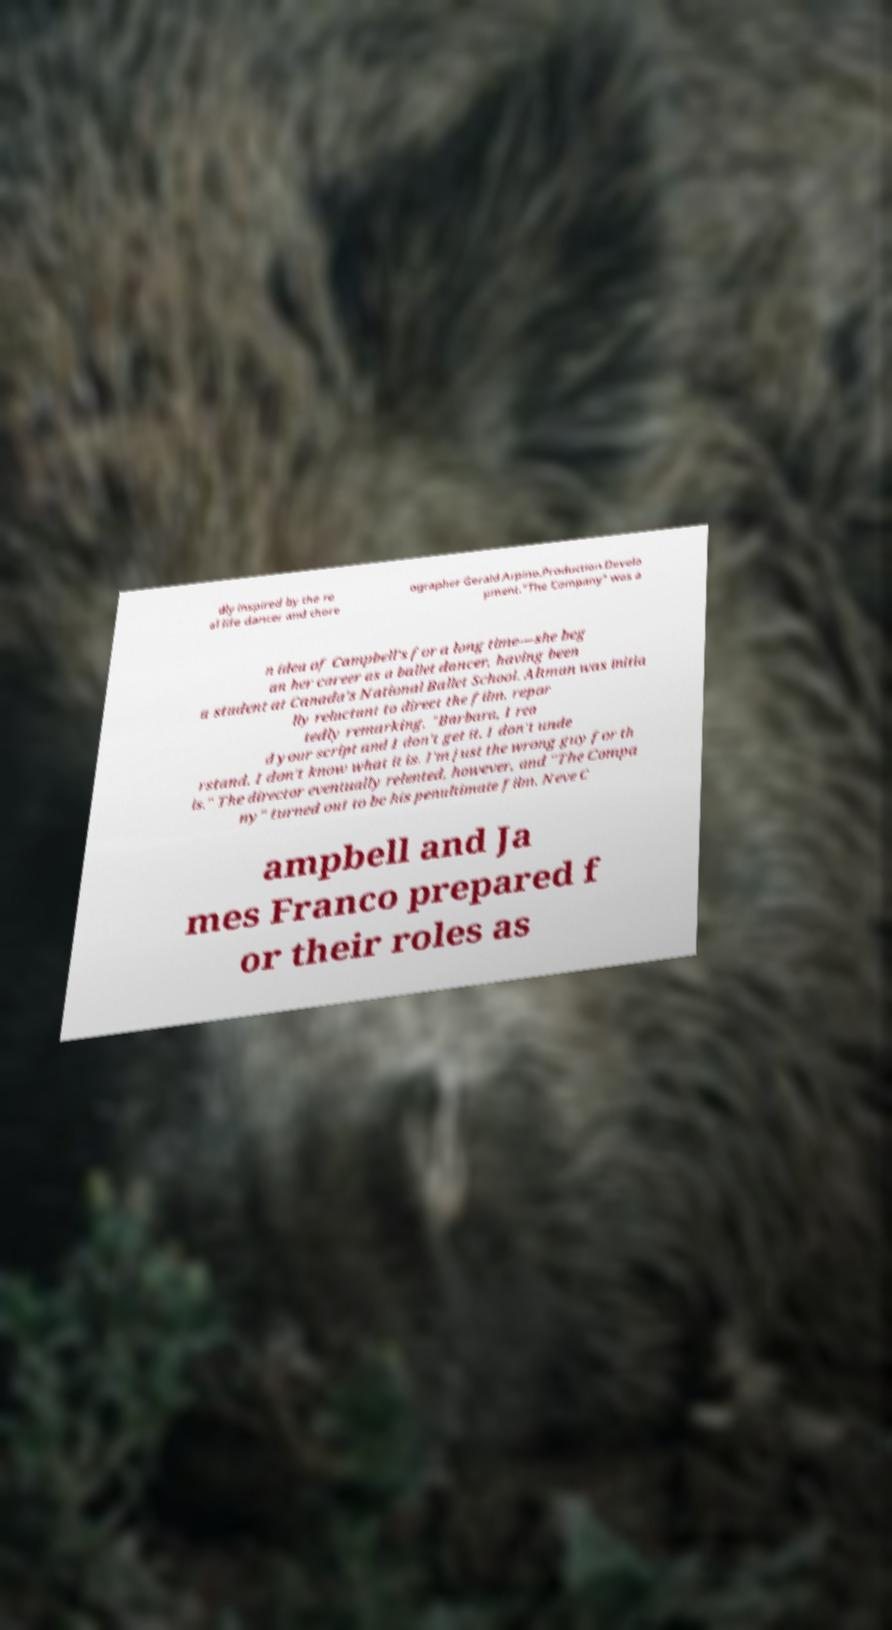Can you read and provide the text displayed in the image?This photo seems to have some interesting text. Can you extract and type it out for me? dly inspired by the re al life dancer and chore ographer Gerald Arpino.Production.Develo pment."The Company" was a n idea of Campbell's for a long time—she beg an her career as a ballet dancer, having been a student at Canada's National Ballet School. Altman was initia lly reluctant to direct the film, repor tedly remarking, "Barbara, I rea d your script and I don't get it. I don't unde rstand. I don't know what it is. I'm just the wrong guy for th is." The director eventually relented, however, and "The Compa ny" turned out to be his penultimate film. Neve C ampbell and Ja mes Franco prepared f or their roles as 